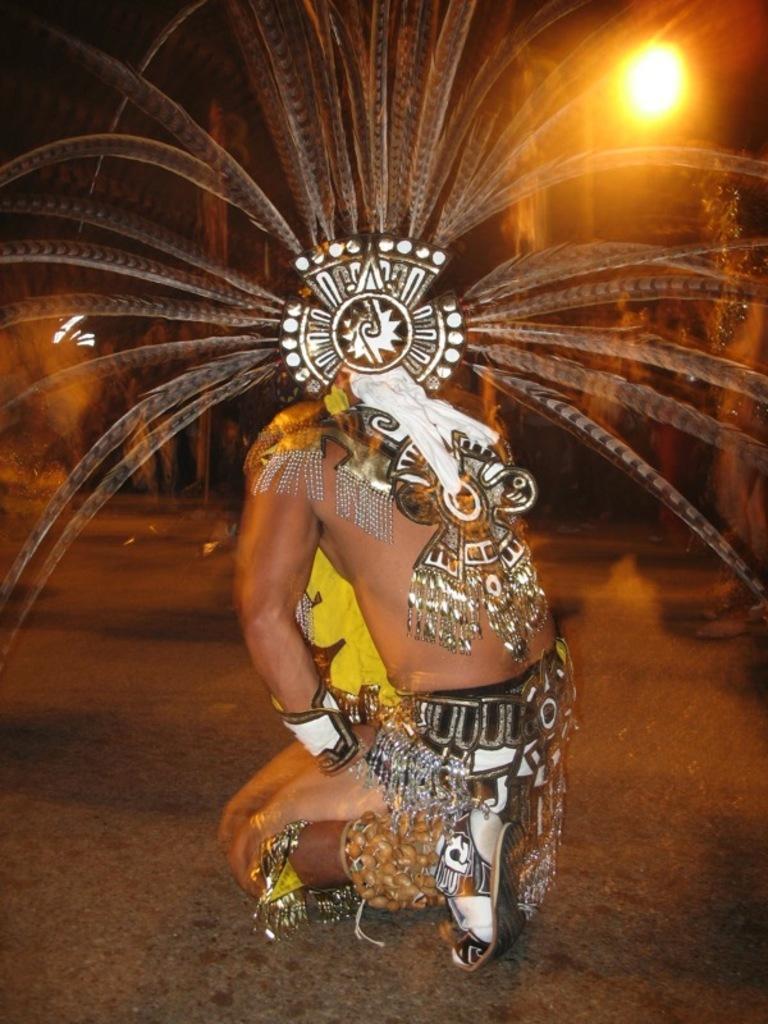Could you give a brief overview of what you see in this image? In this image we can see a person sitting on the ground and wearing a costume. 